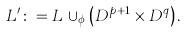Convert formula to latex. <formula><loc_0><loc_0><loc_500><loc_500>L ^ { \prime } \colon = L \, \cup _ { \phi } \left ( D ^ { p + 1 } \times D ^ { q } \right ) .</formula> 